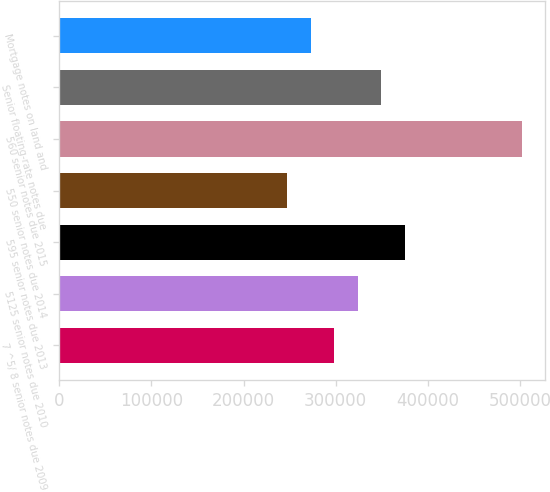Convert chart to OTSL. <chart><loc_0><loc_0><loc_500><loc_500><bar_chart><fcel>7 ^5/ 8 senior notes due 2009<fcel>5125 senior notes due 2010<fcel>595 senior notes due 2013<fcel>550 senior notes due 2014<fcel>560 senior notes due 2015<fcel>Senior floating-rate notes due<fcel>Mortgage notes on land and<nl><fcel>298286<fcel>323766<fcel>374726<fcel>247326<fcel>502127<fcel>349246<fcel>272806<nl></chart> 